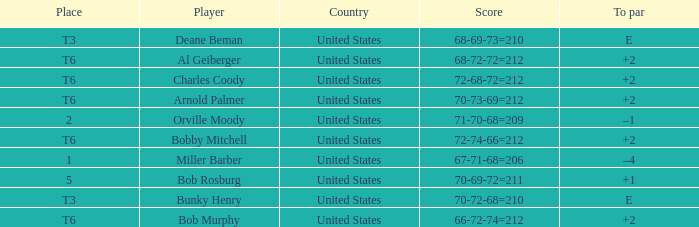What is the score of player bob rosburg? 70-69-72=211. 